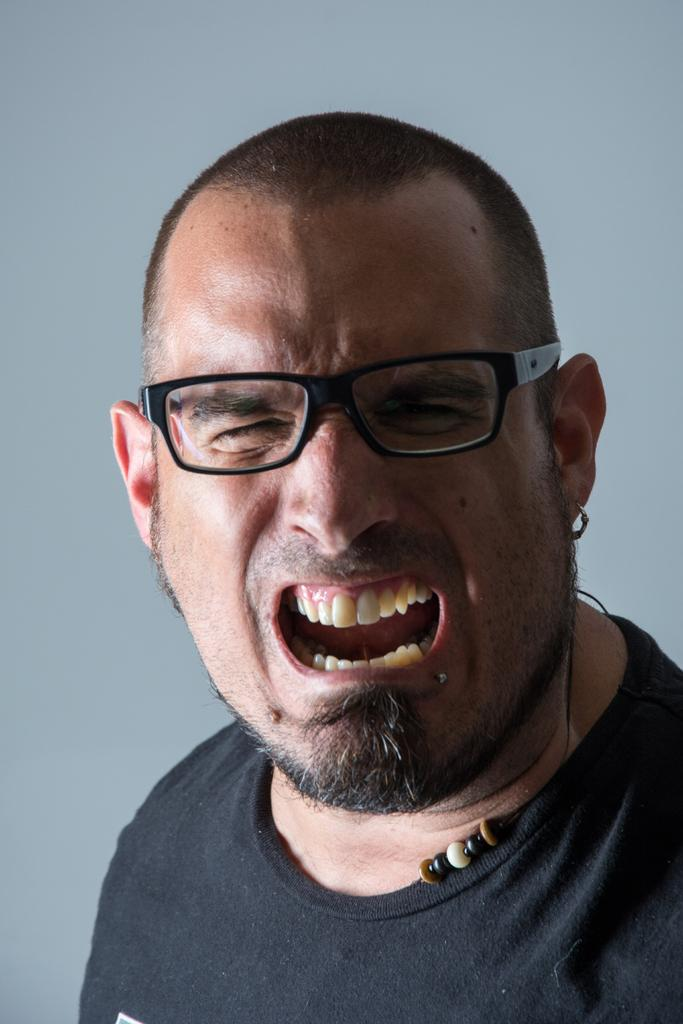What is the main subject of the image? There is a man in the image. What is the man wearing? The man is wearing a black T-shirt. What is the man doing in the image? The man is shouting. What type of eyewear is the man wearing? The man is wearing spectacles. What can be seen in the background of the image? There is a white wall in the background of the image. What time does the clock in the image show? There is no clock present in the image. Who is the owner of the sponge in the image? There is no sponge present in the image. 